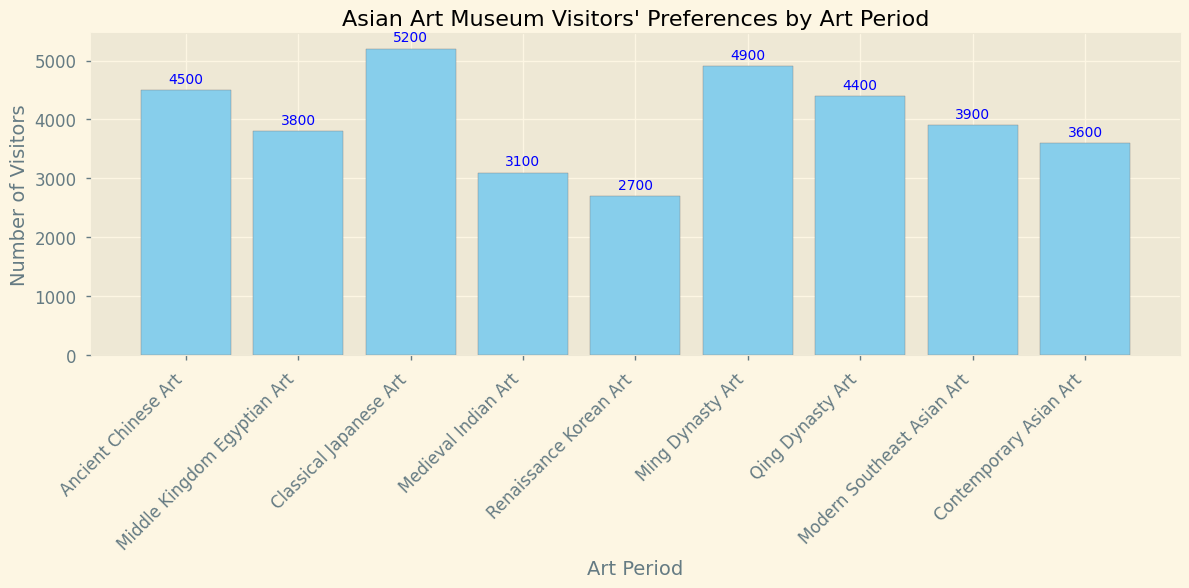What's the total number of visitors across all the art periods? Sum all the visitor numbers from each art period: 4500 + 3800 + 5200 + 3100 + 2700 + 4900 + 4400 + 3900 + 3600 = 36100
Answer: 36100 Which art period had the highest number of visitors? Compare the visitor numbers for all art periods. Classical Japanese Art has the highest with 5200 visitors.
Answer: Classical Japanese Art Which two art periods combined have the lowest total number of visitors? List the visitor numbers and add them in pairs to find the smallest sum. Renaissance Korean Art (2700) + Medieval Indian Art (3100) = 5800, which is the lowest.
Answer: Renaissance Korean Art and Medieval Indian Art By how much does the number of visitors to Classical Japanese Art exceed the number of visitors to Renaissance Korean Art? Subtract the number of visitors to Renaissance Korean Art from the number of visitors to Classical Japanese Art: 5200 - 2700 = 2500
Answer: 2500 What is the average number of visitors per art period? Sum the total number of visitors and divide by the number of periods: 36100 / 9 = 4011.11
Answer: 4011.11 Compare the number of visitors to Ming Dynasty Art and Qing Dynasty Art. Which one is higher and by how much? Subtract Qing Dynasty Art visitors from Ming Dynasty Art visitors: 4900 - 4400 = 500
Answer: Ming Dynasty Art by 500 What's the difference in the number of visitors between Ancient Chinese Art and Contemporary Asian Art? Subtract Contemporary Asian Art visitors from Ancient Chinese Art visitors: 4500 - 3600 = 900
Answer: 900 Which art period is the second most popular based on visitor numbers? Rank the visitor numbers and identify the second highest. Ming Dynasty Art with 4900 visitors is the second most popular.
Answer: Ming Dynasty Art By how much do the visitors of Modern Southeast Asian Art differ from Medieval Indian Art? Subtract Medieval Indian Art visitors from Modern Southeast Asian Art visitors: 3900 - 3100 = 800
Answer: 800 Are there more visitors to Middle Kingdom Egyptian Art or Contemporary Asian Art? Compare the visitor numbers: Middle Kingdom Egyptian Art has 3800 visitors, and Contemporary Asian Art has 3600 visitors.
Answer: Middle Kingdom Egyptian Art 